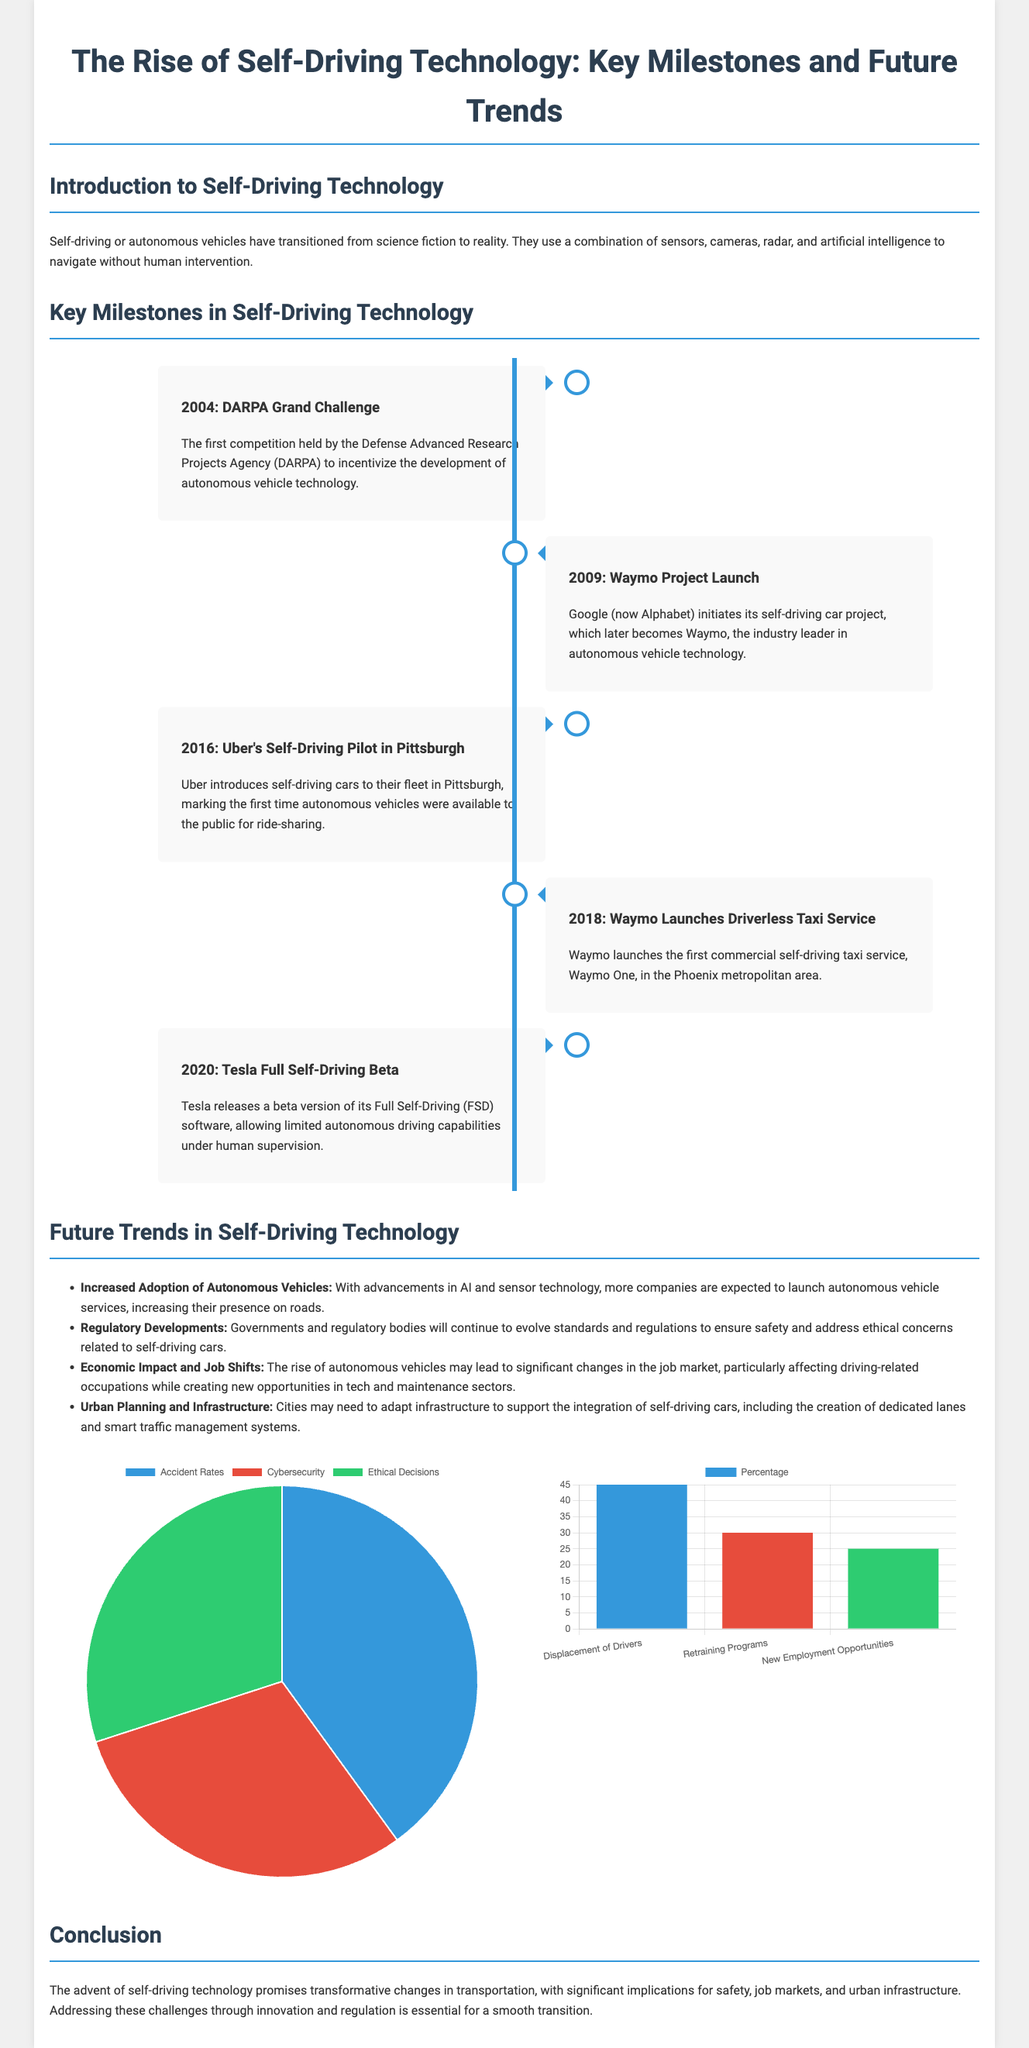What year was the DARPA Grand Challenge? The DARPA Grand Challenge was mentioned as the first competition to incentivize autonomous vehicle technology, held in 2004.
Answer: 2004 Who launched the Waymo project? The document states that the Waymo project was initiated by Google, now known as Alphabet.
Answer: Google What was launched in 2018? The document mentions that in 2018, Waymo launched the first commercial self-driving taxi service, Waymo One.
Answer: Waymo One What percentage of job displacement is associated with drivers? The bar chart indicates that 45% of job displacement is attributed to drivers in the job impact section.
Answer: 45% What are the three safety concerns listed? The pie chart provides three safety concerns: Accident Rates, Cybersecurity, and Ethical Decisions.
Answer: Accident Rates, Cybersecurity, Ethical Decisions Which milestone occurred in 2016? The document states that in 2016, Uber introduced self-driving cars to their fleet in Pittsburgh.
Answer: Uber's Self-Driving Pilot in Pittsburgh What is the focus of future trends according to the document? The document outlines that future trends include increased adoption, regulatory developments, economic impact, and urban planning.
Answer: Increased Adoption of Autonomous Vehicles What percentage refers to new employment opportunities? The document shows that new employment opportunities correspond to 25% in the job impact chart.
Answer: 25% What are the two main types of vehicles being discussed? The document addresses self-driving or autonomous vehicles transitioning from science fiction to reality.
Answer: Self-Driving Vehicles, Autonomous Vehicles 